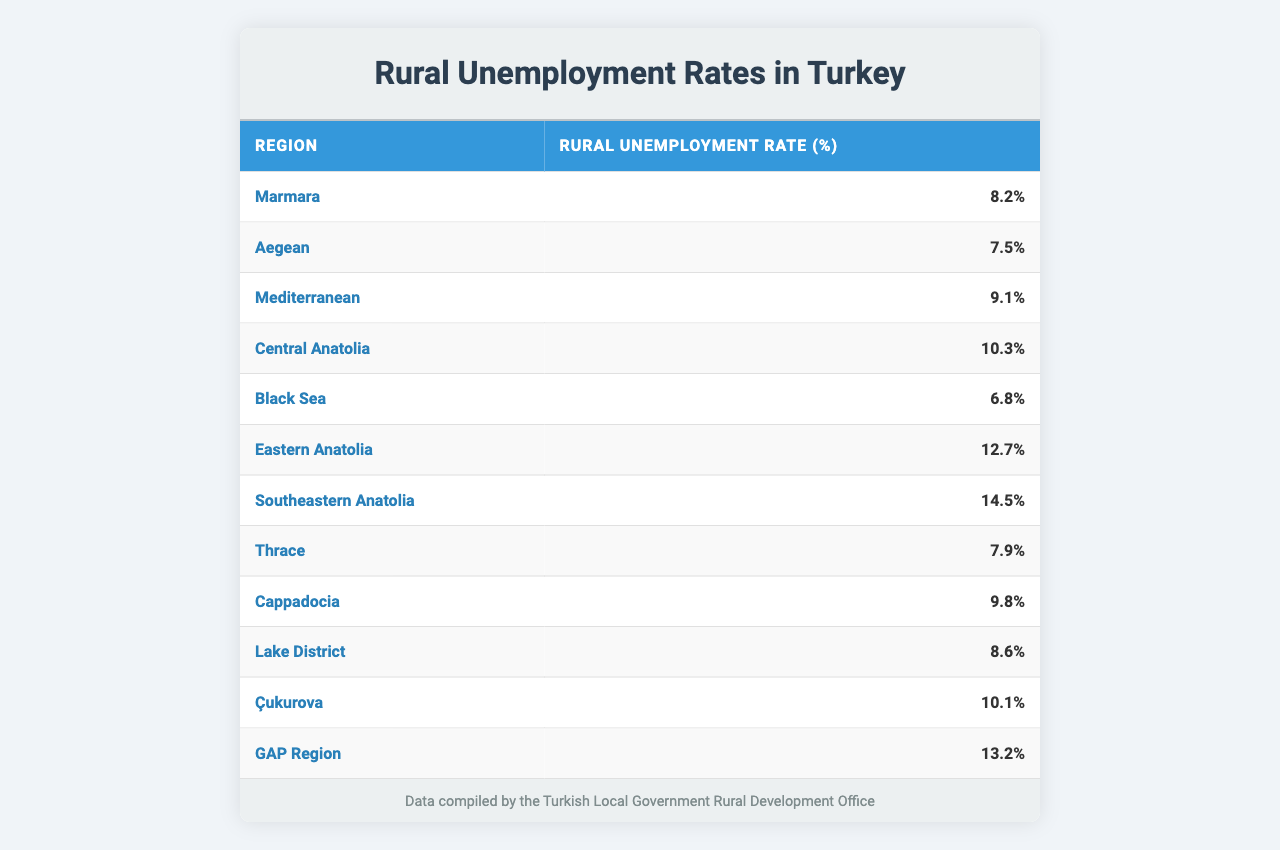What is the rural unemployment rate in the Eastern Anatolia region? The table shows that the rural unemployment rate in the Eastern Anatolia region is 12.7%.
Answer: 12.7% Which region has the highest rural unemployment rate? The table lists the Southeastern Anatolia region with a rural unemployment rate of 14.5%, which is the highest among the regions presented.
Answer: Southeastern Anatolia What is the rural unemployment rate in the Black Sea region compared to the Mediterranean region? According to the table, the Black Sea region has a rural unemployment rate of 6.8%, while the Mediterranean region has a rate of 9.1%. Thus, the Black Sea region's rate is lower by 2.3%.
Answer: 6.8% vs 9.1% What is the average rural unemployment rate across all regions listed? To find the average, add all the unemployment rates: (8.2 + 7.5 + 9.1 + 10.3 + 6.8 + 12.7 + 14.5 + 7.9 + 9.8 + 8.6 + 10.1 + 13.2) = 88.8. There are 12 regions, so the average is 88.8 / 12 = 7.4%.
Answer: 7.4% Is the Aegean region's unemployment rate higher than the average rate? The average rate calculated is 7.4%, while the Aegean region's unemployment rate is 7.5%. Since 7.5% is greater than 7.4%, this statement is true.
Answer: Yes How much higher is the unemployment rate in the GAP Region compared to the Black Sea Region? The GAP Region has an unemployment rate of 13.2%, and the Black Sea region has a rate of 6.8%. The difference is 13.2 - 6.8 = 6.4%.
Answer: 6.4% Which two regions have a rural unemployment rate closest to each other? Comparing the rates, the Aegean (7.5%) and Thrace (7.9%) regions have the closest rates, differing by only 0.4%.
Answer: Aegean and Thrace If we ignore the Southeastern Anatolia region, what is the maximum unemployment rate among the other regions? Excluding Southeastern Anatolia (14.5%), the highest remaining rate is from Eastern Anatolia at 12.7%.
Answer: 12.7% Which regions have unemployment rates below 10%? The regions with unemployment rates below 10% are Marmara (8.2%), Aegean (7.5%), Black Sea (6.8%), Lake District (8.6%), and Thrace (7.9%).
Answer: Marmara, Aegean, Black Sea, Lake District, Thrace What percentage of regions have a rural unemployment rate above 10%? There are 12 regions, and 5 of them (Central Anatolia, Eastern Anatolia, Southeastern Anatolia, Cappadocia, and GAP Region) have rates above 10%. Therefore, (5 / 12) * 100 = 41.67%, which rounds to approximately 42%.
Answer: 42% 